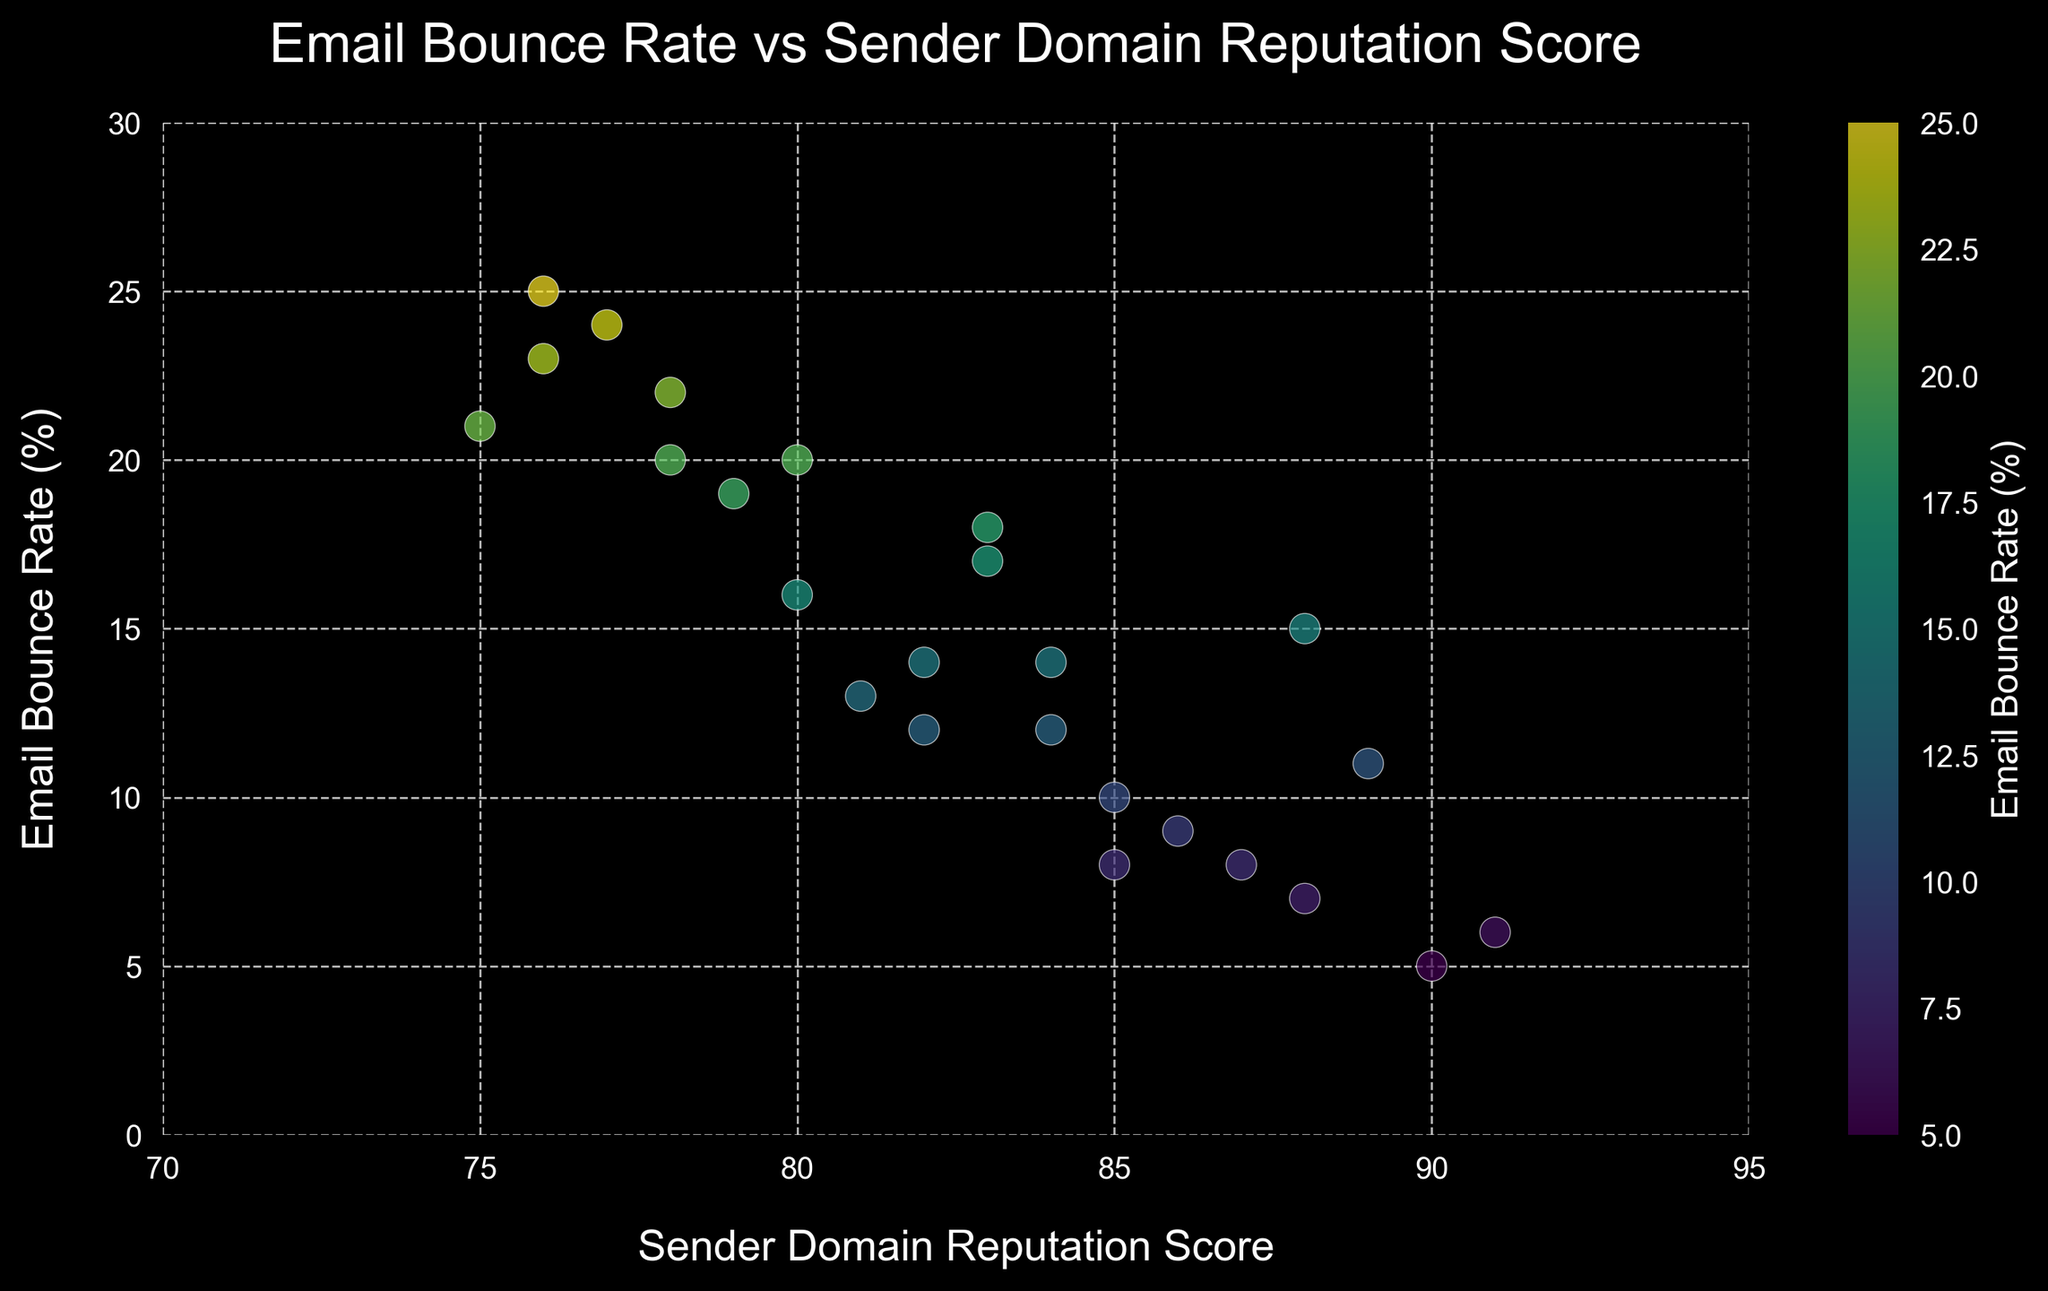Which domain reputation score has the lowest email bounce rate? Locate the scatter plot point with the lowest 'Email Bounce Rate' on the y-axis, then read its corresponding 'Sender Domain Reputation Score' on the x-axis. The lowest email bounce rate occurs at the domain reputation score of 91.
Answer: 91 What is the average email bounce rate for domains with a reputation score above 85? Identify all scatter plot points with a 'Sender Domain Reputation Score' above 85. Their 'Email Bounce Rates' are: 5, 10, 15, 8, 11, 9, 14, 7, 6, 8. Sum these rates to get 93. Since there are 10 points, the average bounce rate is 93/10 = 9.3.
Answer: 9.3 How does the bounce rate correlate with the domain reputation score? Observe the overall trend of the scatter plot. As the 'Sender Domain Reputation Score' increases (moves right on the x-axis), the 'Email Bounce Rate' generally decreases (moves down on the y-axis). Therefore, there is a negative correlation between bounce rate and domain reputation score.
Answer: Negative correlation When comparing scores of 75 and 90, which one has a higher corresponding email bounce rate? Find points on the scatter plot with 'Sender Domain Reputation Scores' of 75 and 90. Look at their 'Email Bounce Rates'. For a score of 75, bounce rates are 21; for 90, it's 5. Hence, 75 has a higher email bounce rate.
Answer: 75 Describe the color pattern used in the scatter plot. How does color represent email bounce rates? The scatter plot uses a color gradient (from blue to green to yellow) to represent the 'Email Bounce Rates'. Lower rates are shown in blue, intermediate rates in green, and higher rates in yellow. This color mapping helps visually differentiate among various bounce rates.
Answer: Color gradient representing bounce rates What is the total range of email bounce rates observed in the plot? Identify the highest and lowest email bounce rates directly from the scatter plot's y-axis. The highest rate is 25% and the lowest rate is 5%. Thus, the range is 25 - 5 = 20%.
Answer: 20% Are there any points with an email bounce rate above 20%? If yes, how many? Examine the scatter plot for points above the 20% mark on the y-axis. These points correspond to bounce rates of 22%, 25%, 24%, 21%, and 23%. There are 5 points in total.
Answer: 5 points Which domain reputation scores are associated with bounce rates of 12% and above? Identify all scatter plot points with 'Email Bounce Rates' of 12% or greater. The corresponding 'Sender Domain Reputation Scores' are: 80, 88, 82, 78, 83, 79, 81, 75, 80, 76, 83, 84, and 84.
Answer: 80, 88, 82, 78, 83, 79, 81, 75, 80, 76, 83, 84, 84 What is the average reputation score for points with an email bounce rate of 15% and higher? Isolate scatter plot points with bounce rates greater or equal to 15. The 'Sender Domain Reputation Scores' are: 80, 83, 79, 75, 80, 76, 83. Sum these scores: 556. Since there are 7 points, the average score is 556/7 = 79.43.
Answer: 79.43 